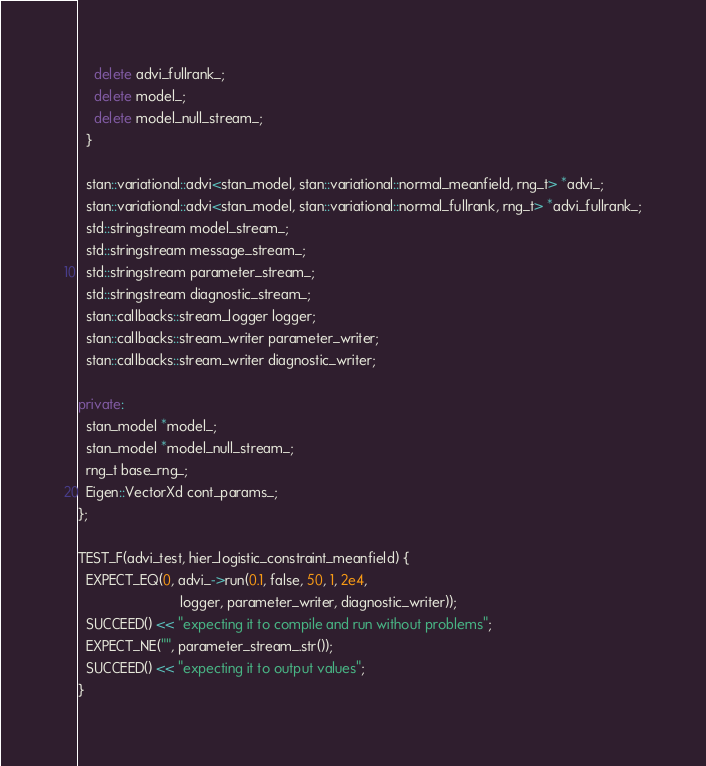Convert code to text. <code><loc_0><loc_0><loc_500><loc_500><_C++_>    delete advi_fullrank_;
    delete model_;
    delete model_null_stream_;
  }

  stan::variational::advi<stan_model, stan::variational::normal_meanfield, rng_t> *advi_;
  stan::variational::advi<stan_model, stan::variational::normal_fullrank, rng_t> *advi_fullrank_;
  std::stringstream model_stream_;
  std::stringstream message_stream_;
  std::stringstream parameter_stream_;
  std::stringstream diagnostic_stream_;
  stan::callbacks::stream_logger logger;
  stan::callbacks::stream_writer parameter_writer;
  stan::callbacks::stream_writer diagnostic_writer;

private:
  stan_model *model_;
  stan_model *model_null_stream_;
  rng_t base_rng_;
  Eigen::VectorXd cont_params_;
};

TEST_F(advi_test, hier_logistic_constraint_meanfield) {
  EXPECT_EQ(0, advi_->run(0.1, false, 50, 1, 2e4,
                          logger, parameter_writer, diagnostic_writer));
  SUCCEED() << "expecting it to compile and run without problems";
  EXPECT_NE("", parameter_stream_.str());
  SUCCEED() << "expecting it to output values";
}
</code> 